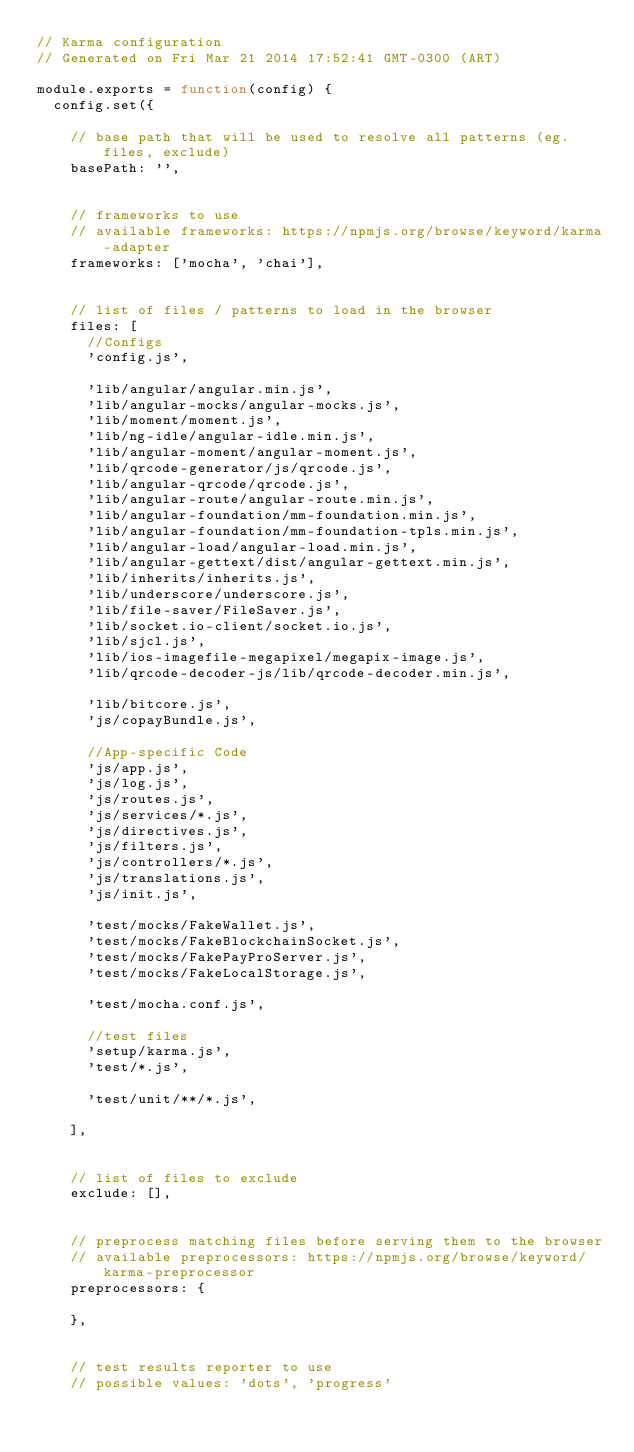<code> <loc_0><loc_0><loc_500><loc_500><_JavaScript_>// Karma configuration
// Generated on Fri Mar 21 2014 17:52:41 GMT-0300 (ART)

module.exports = function(config) {
  config.set({

    // base path that will be used to resolve all patterns (eg. files, exclude)
    basePath: '',


    // frameworks to use
    // available frameworks: https://npmjs.org/browse/keyword/karma-adapter
    frameworks: ['mocha', 'chai'],


    // list of files / patterns to load in the browser
    files: [
      //Configs
      'config.js',

      'lib/angular/angular.min.js',
      'lib/angular-mocks/angular-mocks.js',
      'lib/moment/moment.js',
      'lib/ng-idle/angular-idle.min.js',
      'lib/angular-moment/angular-moment.js',
      'lib/qrcode-generator/js/qrcode.js',
      'lib/angular-qrcode/qrcode.js',
      'lib/angular-route/angular-route.min.js',
      'lib/angular-foundation/mm-foundation.min.js',
      'lib/angular-foundation/mm-foundation-tpls.min.js',
      'lib/angular-load/angular-load.min.js',
      'lib/angular-gettext/dist/angular-gettext.min.js',
      'lib/inherits/inherits.js',
      'lib/underscore/underscore.js',
      'lib/file-saver/FileSaver.js',
      'lib/socket.io-client/socket.io.js',
      'lib/sjcl.js',
      'lib/ios-imagefile-megapixel/megapix-image.js',
      'lib/qrcode-decoder-js/lib/qrcode-decoder.min.js',

      'lib/bitcore.js',
      'js/copayBundle.js',

      //App-specific Code
      'js/app.js',
      'js/log.js',
      'js/routes.js',
      'js/services/*.js',
      'js/directives.js',
      'js/filters.js',
      'js/controllers/*.js',
      'js/translations.js',
      'js/init.js',

      'test/mocks/FakeWallet.js',
      'test/mocks/FakeBlockchainSocket.js',
      'test/mocks/FakePayProServer.js',
      'test/mocks/FakeLocalStorage.js',

      'test/mocha.conf.js',

      //test files
      'setup/karma.js',
      'test/*.js',

      'test/unit/**/*.js',

    ],


    // list of files to exclude
    exclude: [],


    // preprocess matching files before serving them to the browser
    // available preprocessors: https://npmjs.org/browse/keyword/karma-preprocessor
    preprocessors: {

    },


    // test results reporter to use
    // possible values: 'dots', 'progress'</code> 